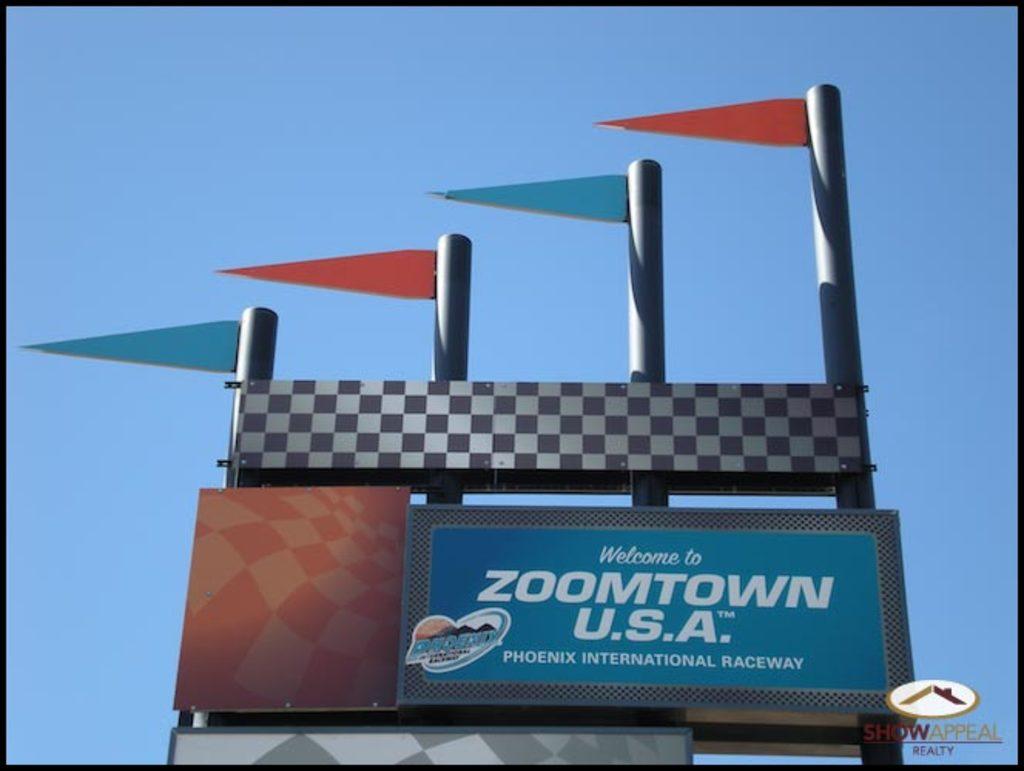What city is on the sign?
Keep it short and to the point. Phoenix. 